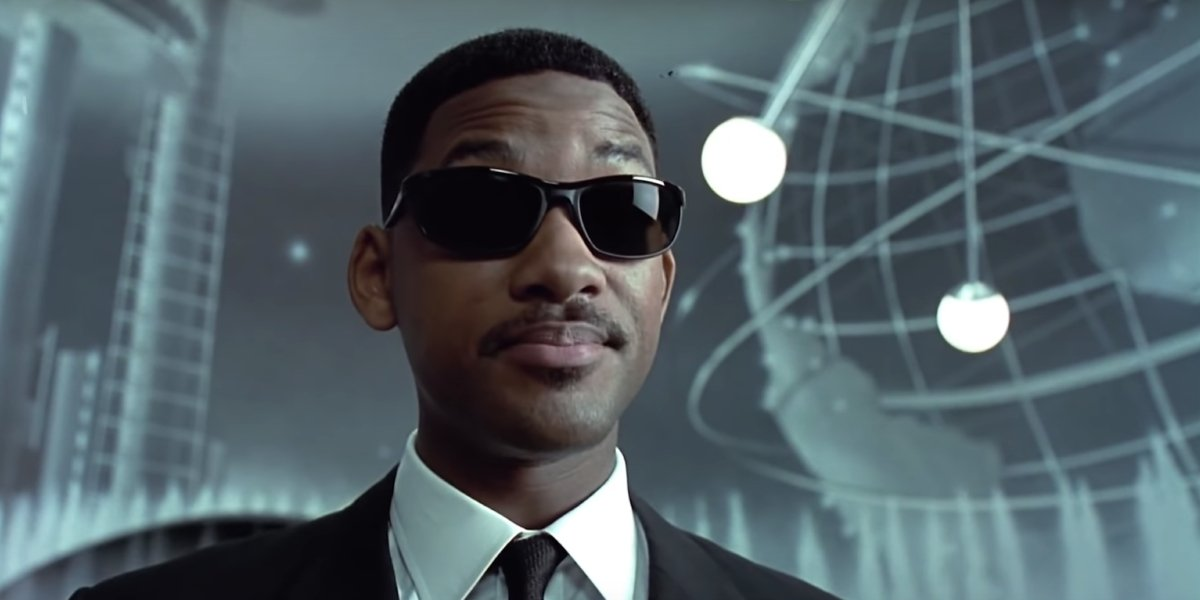Write a detailed description of the given image. In this image, we see a well-known actor dressed impeccably as a secret agent. He is wearing a classic black suit paired with a crisp white shirt and a black tie, all complemented by stylish, black sunglasses with silver frames. The actor exudes a serious and focused demeanor as he gazes directly into the camera. The backdrop adds to the futuristic ambiance, featuring a large metallic globe and various scientific apparatus, suggestive of advanced technology. These elements, along with the actor’s poised and authoritative expression, capture the essence of a quintessential secret agent against a high-tech, science-fiction setting. 